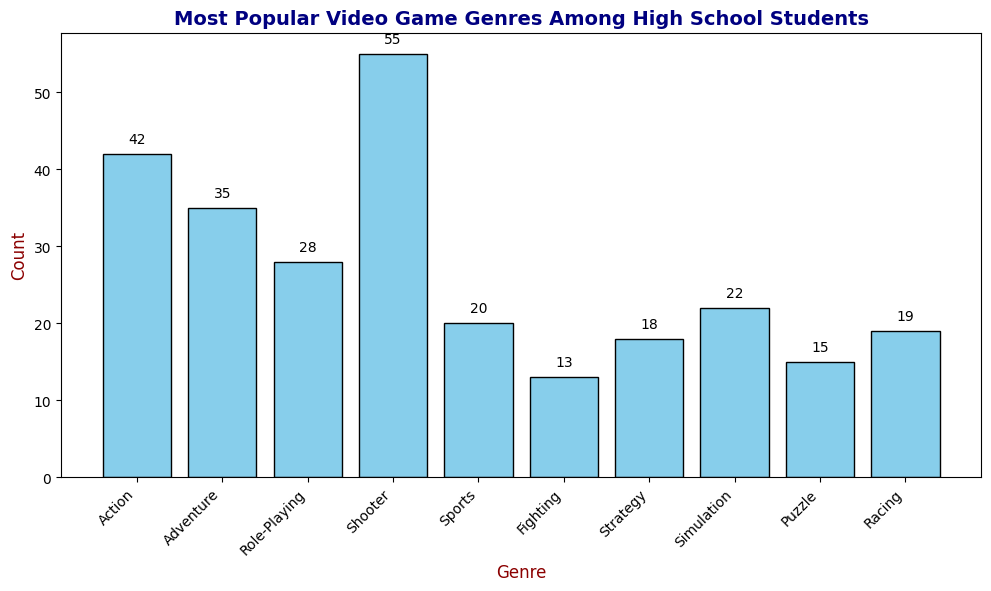Which video game genre is the most popular among high school students? The genre with the highest bar represents the most popular one. The Shooter genre has the tallest bar with a count of 55.
Answer: Shooter Which is the least popular genre among high school students? The genre with the shortest bar represents the least popular one. The Fighting genre has the shortest bar with a count of 13.
Answer: Fighting What is the difference in popularity between the Shooter and Role-Playing genres? From the chart, Shooter has a count of 55, and Role-Playing has a count of 28. The difference is 55 - 28 = 27.
Answer: 27 Which genres have counts greater than 25 but less than 45? Inspecting the bars, the genres with counts in this range are Action (42), Adventure (35), and Role-Playing (28).
Answer: Action, Adventure, Role-Playing What is the total count of students who prefer Sports, Fighting, and Racing genres combined? Add the counts of Sports (20), Fighting (13), and Racing (19) together: 20 + 13 + 19 = 52.
Answer: 52 What is the average count of students across all genres? Sum the counts of all genres: 42 + 35 + 28 + 55 + 20 + 13 + 18 + 22 + 15 + 19 = 267. Divide by the number of genres, which is 10: 267 / 10 = 26.7.
Answer: 26.7 How many more students prefer Simulation over Puzzle genres? From the chart, Simulation has a count of 22, and Puzzle has a count of 15. The difference is 22 - 15 = 7.
Answer: 7 List the genres that have counts listed on top of their bars. All bars have counts listed on top. The genres are Action, Adventure, Role-Playing, Shooter, Sports, Fighting, Strategy, Simulation, Puzzle, and Racing.
Answer: Action, Adventure, Role-Playing, Shooter, Sports, Fighting, Strategy, Simulation, Puzzle, Racing 